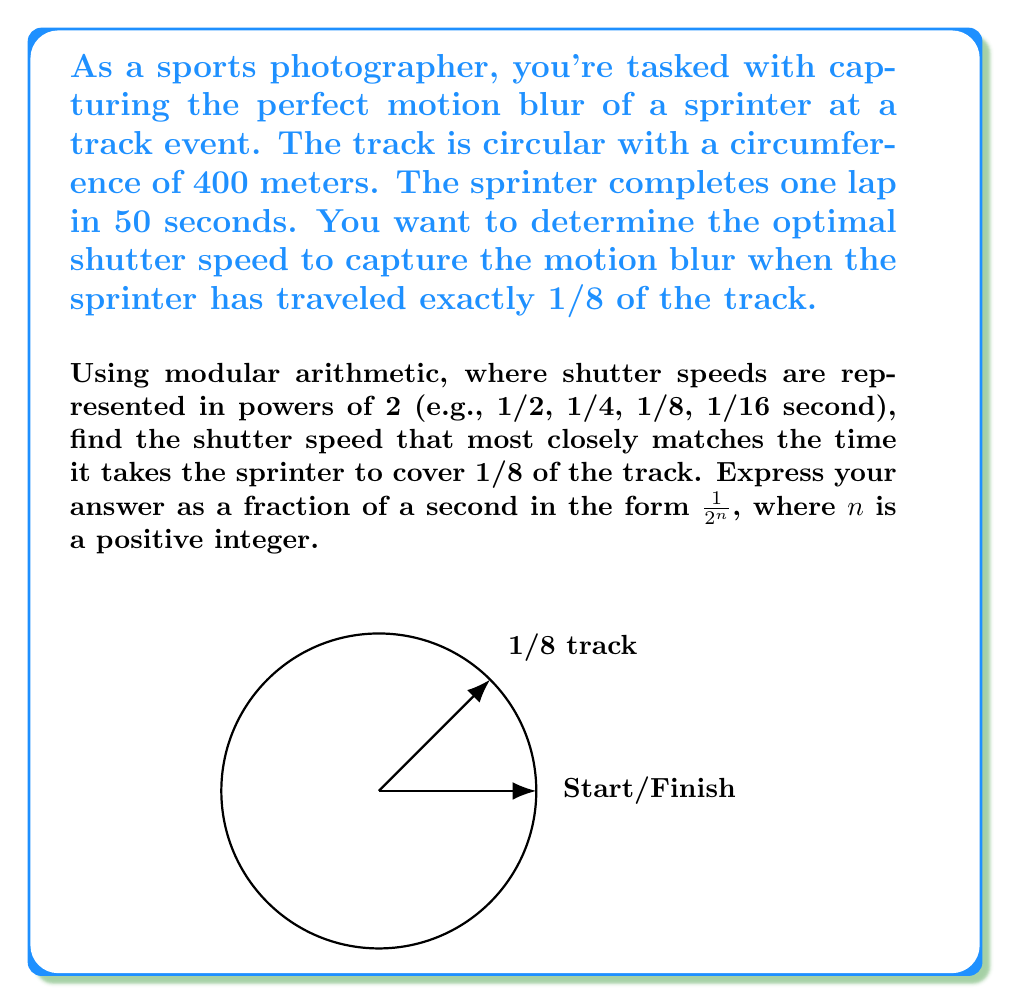Teach me how to tackle this problem. Let's approach this step-by-step:

1) First, we need to calculate the time it takes the sprinter to cover 1/8 of the track.
   - Total distance of track = 400 meters
   - Time for one lap = 50 seconds
   - Distance for 1/8 of track = $400 \times \frac{1}{8} = 50$ meters
   - Time for 1/8 of track = $50 \times \frac{1}{8} = 6.25$ seconds

2) Now, we need to find the closest shutter speed in the form $\frac{1}{2^n}$ to 6.25 seconds.

3) Let's list out some values of $\frac{1}{2^n}$:
   - $\frac{1}{2^1} = 0.5$ seconds
   - $\frac{1}{2^2} = 0.25$ seconds
   - $\frac{1}{2^3} = 0.125$ seconds
   - $\frac{1}{2^4} = 0.0625$ seconds
   - $\frac{1}{2^5} = 0.03125$ seconds

4) Using modular arithmetic, we can represent 6.25 seconds as:
   $6.25 \equiv 0.25 \pmod{1}$

5) From our list, we can see that $\frac{1}{2^2} = 0.25$ seconds is the closest match to 0.25 in our modular representation.

Therefore, the optimal shutter speed is $\frac{1}{2^2} = \frac{1}{4}$ second.
Answer: $\frac{1}{4}$ second 